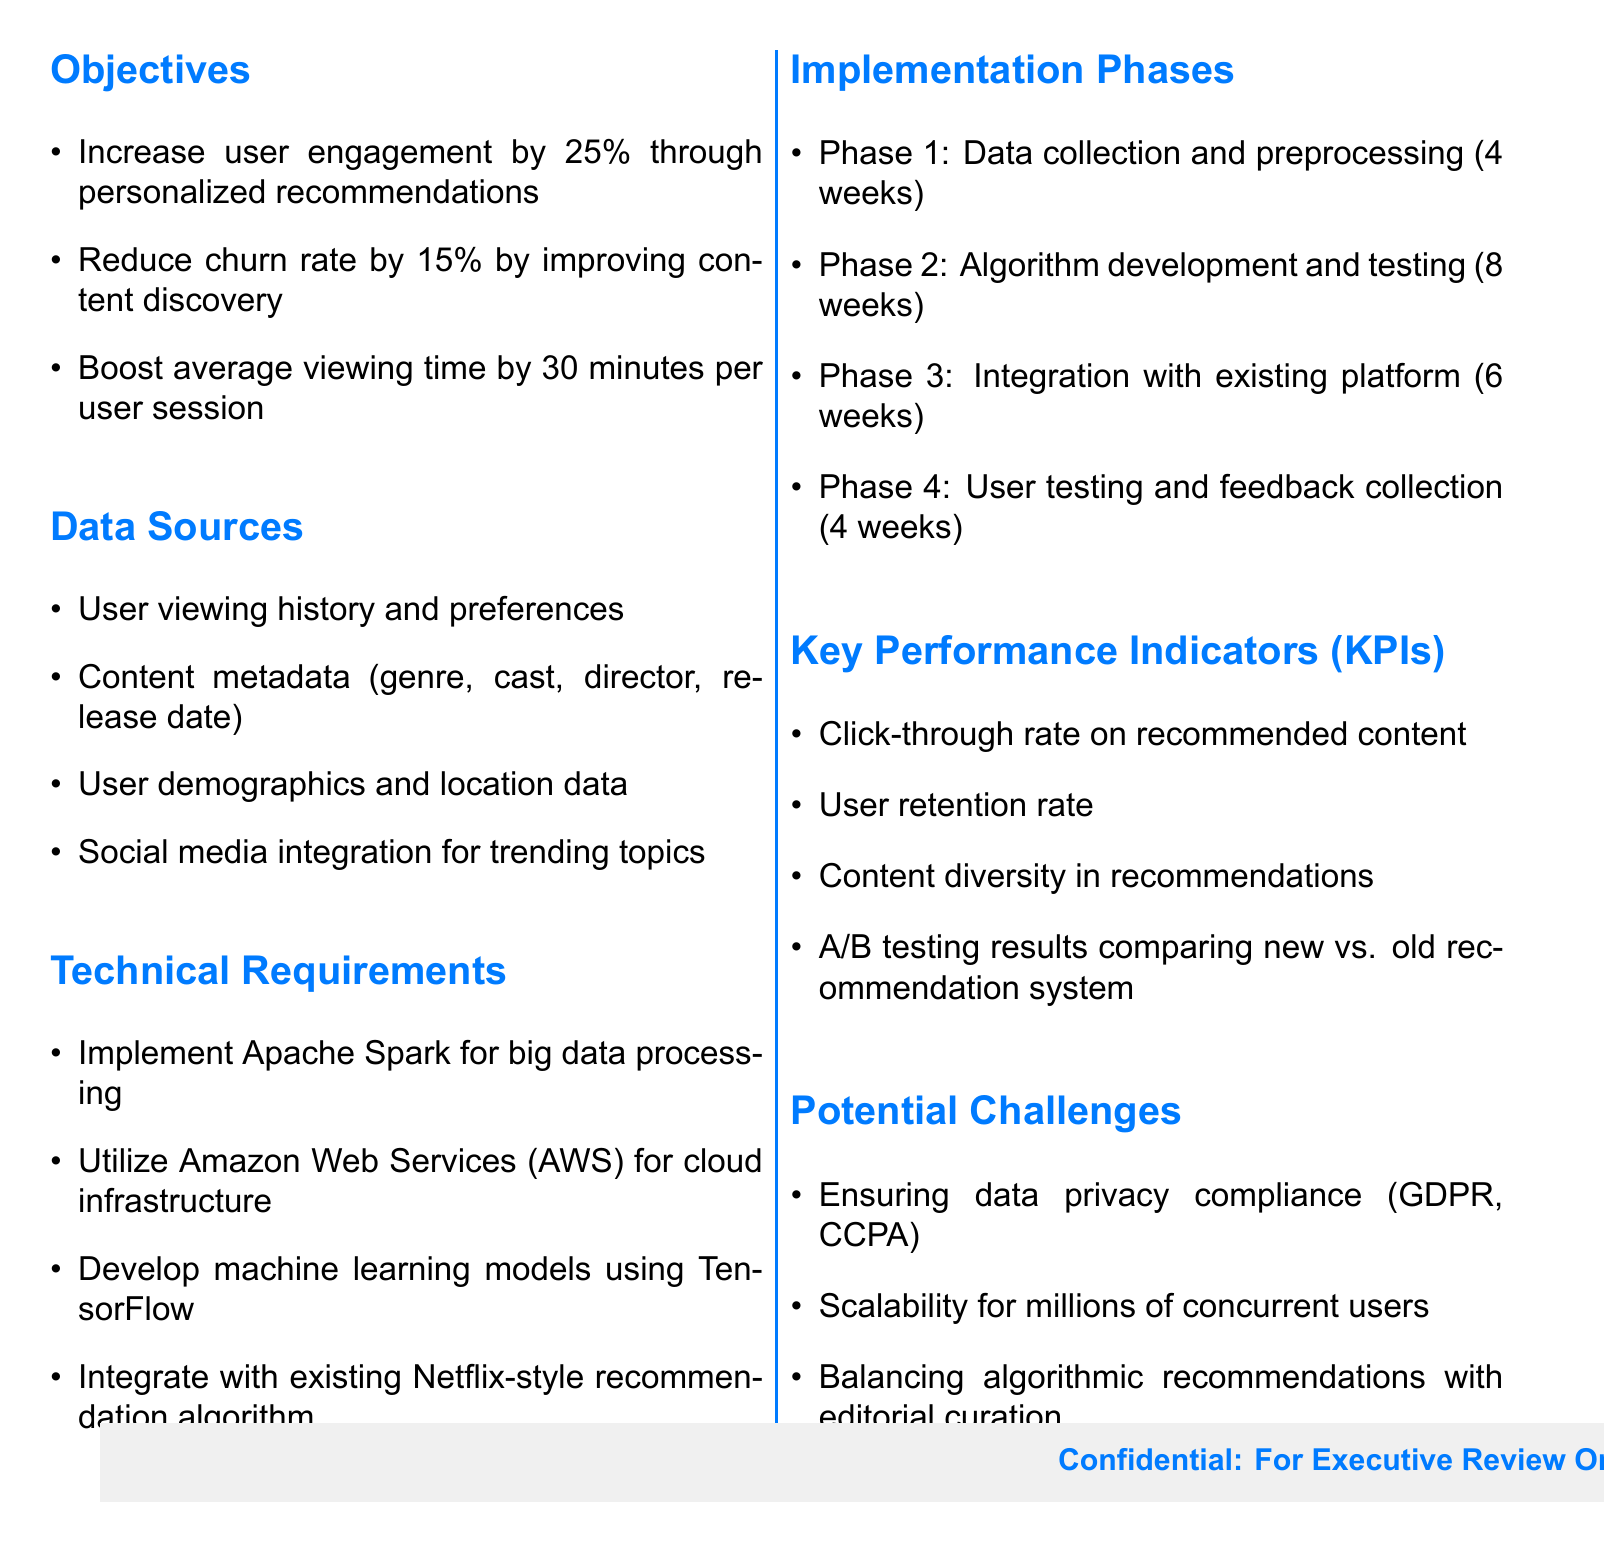What is the main objective regarding user engagement? The document states that the objective is to increase user engagement through personalized recommendations.
Answer: 25% What is the first phase of implementation? The first phase of implementation is data collection and preprocessing, which is detailed in the implementation phases section.
Answer: Data collection and preprocessing (4 weeks) What cloud infrastructure is proposed for use? The document specifies the use of Amazon Web Services for cloud infrastructure.
Answer: Amazon Web Services (AWS) How much is the targeted reduction in churn rate? The document provides the target of reducing the churn rate as part of the objectives.
Answer: 15% What type of model will be developed for recommendations? The document mentions the development of machine learning models as part of the technical requirements.
Answer: Machine learning models using TensorFlow What is one of the key performance indicators for content recommendations? The document lists different key performance indicators, one of which is the click-through rate on recommended content.
Answer: Click-through rate on recommended content What is a potential challenge mentioned in the document? The document outlines several potential challenges, including data privacy compliance.
Answer: Ensuring data privacy compliance (GDPR, CCPA) In how many weeks is the user testing phase planned? The document specifies the duration of the user testing phase in the implementation phases section.
Answer: 4 weeks 